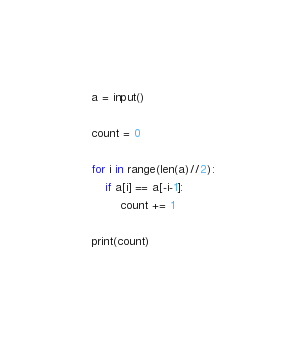Convert code to text. <code><loc_0><loc_0><loc_500><loc_500><_Python_>a = input()
 
count = 0
 
for i in range(len(a)//2):
    if a[i] == a[-i-1]:
        count += 1
 
print(count)</code> 